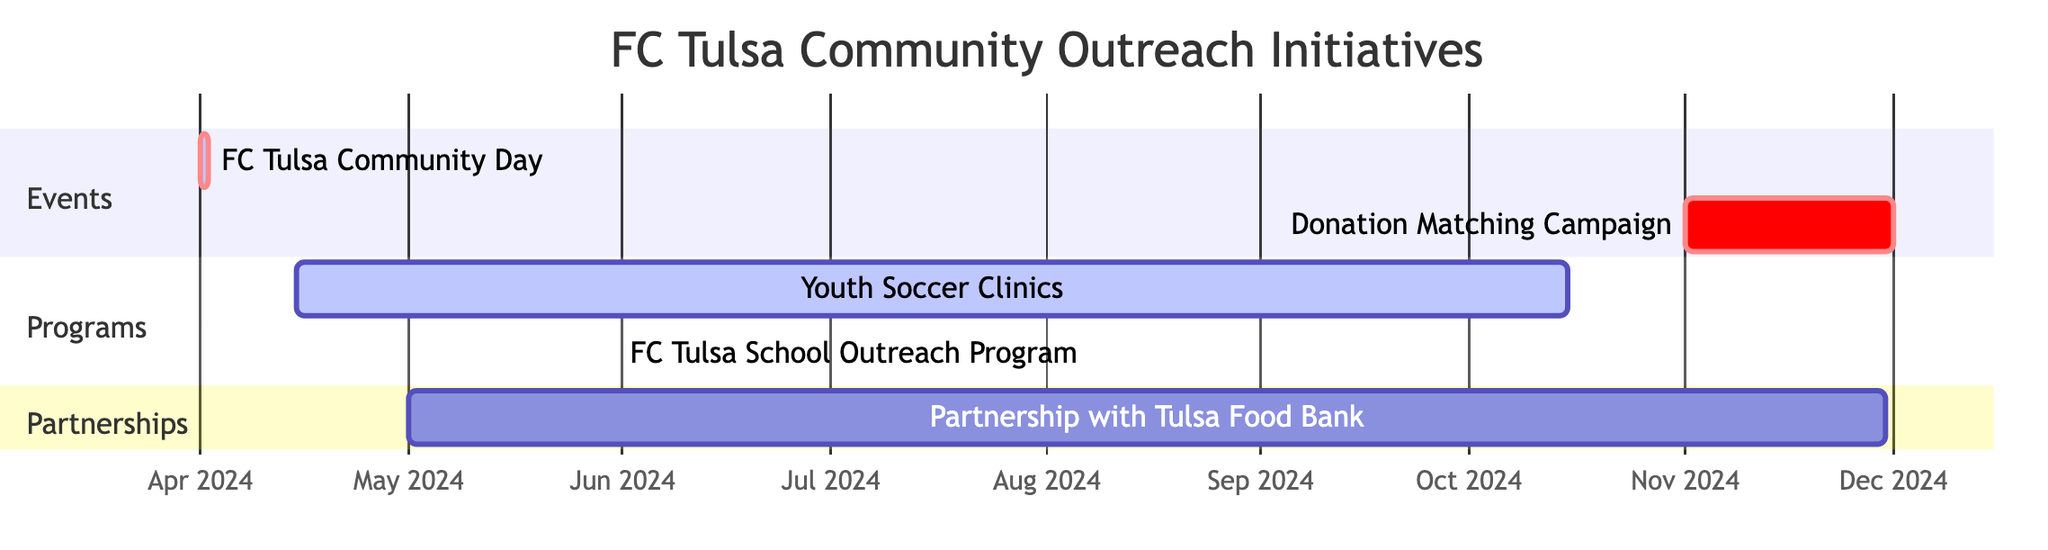What is the duration of the Youth Soccer Clinics? The Youth Soccer Clinics start on April 15, 2024, and end on October 15, 2024. To find the duration, we calculate the time from start to end, which is six months.
Answer: six months How many charity events are scheduled in 2024? In the Gantt Chart, “FC Tulsa Community Day” and “Donation Matching Campaign” are categorized as events. Therefore, there are two charity events scheduled in 2024.
Answer: two When does the Partnership with Tulsa Food Bank start? From the diagram, the start date for the Partnership with Tulsa Food Bank is May 1, 2024. This information can be directly read from the timeline under the "Partnerships" section.
Answer: May 1, 2024 Which initiative overlaps with the FC Tulsa Community Day? The FC Tulsa Community Day takes place on April 1, 2024, and the Youth Soccer Clinics begin shortly after, on April 15, 2024. Both events are within the same month, meaning the Youth Soccer Clinics initiates after the Community Day.
Answer: Youth Soccer Clinics What is the total length of time the FC Tulsa School Outreach Program runs? The FC Tulsa School Outreach Program starts on September 1, 2024, and ends on May 31, 2025. To calculate total timespan, we consider it spans over nine months; however, this can also be counted by months from September to May in the following year.
Answer: nine months What part of the year does the Donation Matching Campaign take place? The Donation Matching Campaign is scheduled from November 1, 2024, to November 30, 2024, which is the entire month of November. This timeframe is the only month indicated for this initiative.
Answer: November How many community outreach initiatives are listed in the Gantt Chart? The chart lists a total of five community outreach initiatives: FC Tulsa Community Day, Youth Soccer Clinics, Partnership with Tulsa Food Bank, FC Tulsa School Outreach Program, and Donation Matching Campaign. Counting each, we find there are five initiatives in total.
Answer: five 